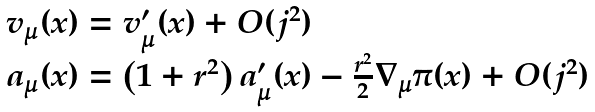<formula> <loc_0><loc_0><loc_500><loc_500>\begin{array} { l } v _ { \mu } ( x ) = v _ { \mu } ^ { \prime } ( x ) + O ( j ^ { 2 } ) \\ a _ { \mu } ( x ) = \left ( 1 + r ^ { 2 } \right ) a _ { \mu } ^ { \prime } ( x ) - \frac { r ^ { 2 } } { 2 } \nabla _ { \mu } \pi ( x ) + O ( j ^ { 2 } ) \end{array}</formula> 